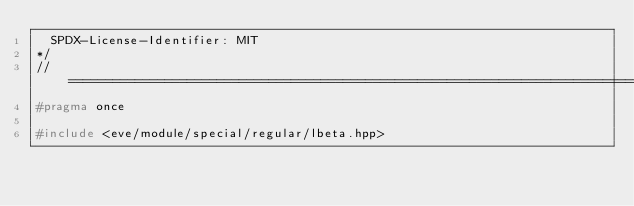Convert code to text. <code><loc_0><loc_0><loc_500><loc_500><_C++_>  SPDX-License-Identifier: MIT
*/
//==================================================================================================
#pragma once

#include <eve/module/special/regular/lbeta.hpp>
</code> 